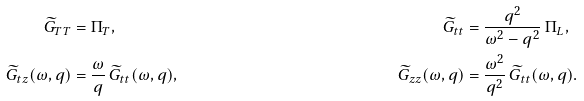Convert formula to latex. <formula><loc_0><loc_0><loc_500><loc_500>\widetilde { G } _ { T T } & = \Pi _ { T } , & \widetilde { G } _ { t t } & = \frac { q ^ { 2 } } { \omega ^ { 2 } - q ^ { 2 } } \, \Pi _ { L } , \\ \widetilde { G } _ { t z } ( \omega , q ) & = \frac { \omega } { q } \, \widetilde { G } _ { t t } ( \omega , q ) , & \widetilde { G } _ { z z } ( \omega , q ) & = \frac { \omega ^ { 2 } } { q ^ { 2 } } \, \widetilde { G } _ { t t } ( \omega , q ) .</formula> 